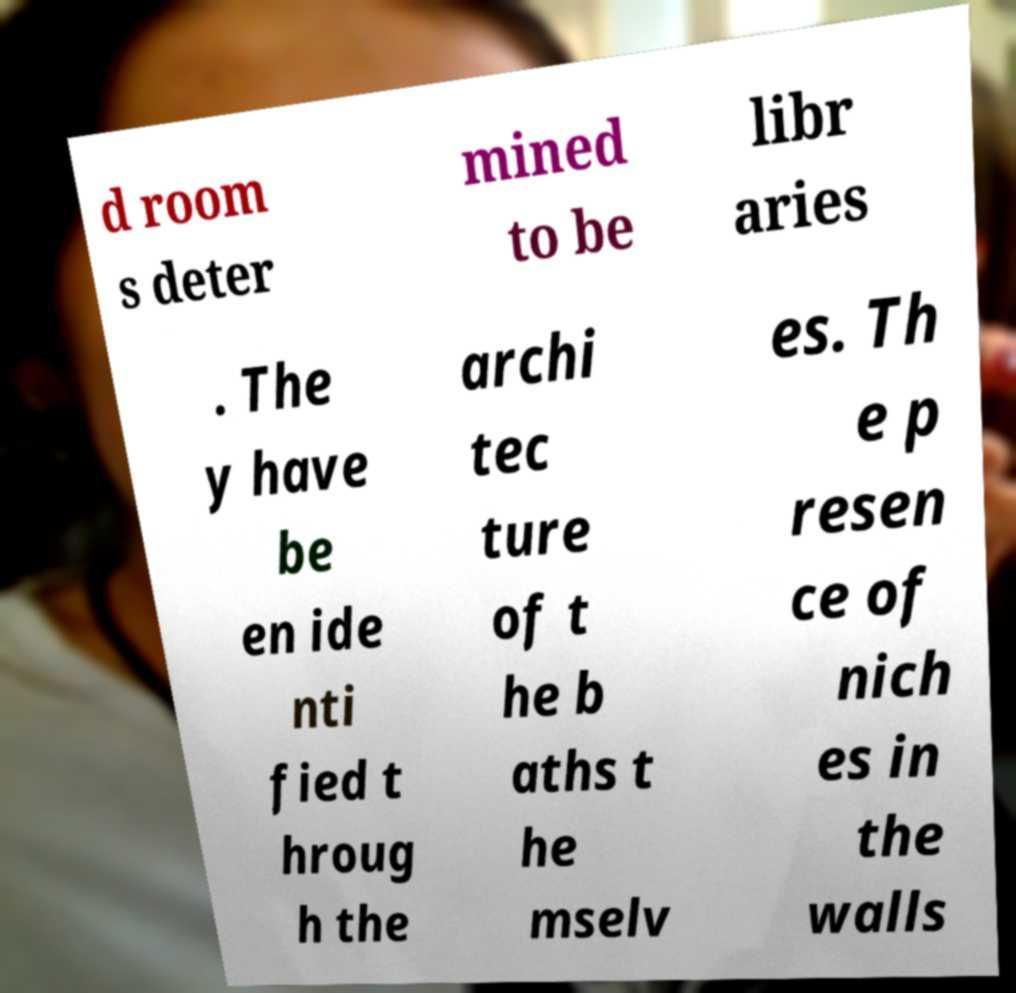Can you read and provide the text displayed in the image?This photo seems to have some interesting text. Can you extract and type it out for me? d room s deter mined to be libr aries . The y have be en ide nti fied t hroug h the archi tec ture of t he b aths t he mselv es. Th e p resen ce of nich es in the walls 